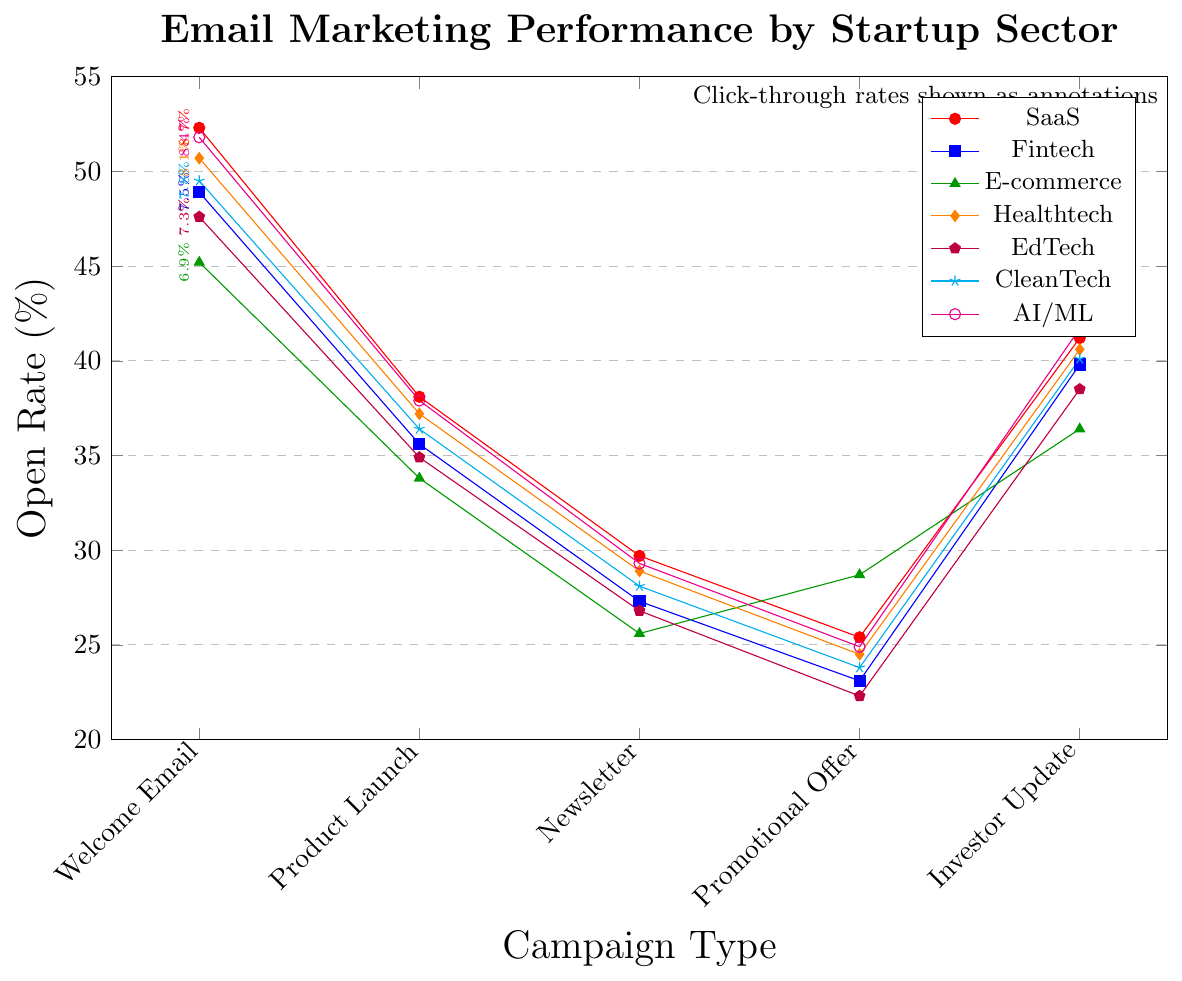How do the open rates of Welcome Emails compare across sectors? The highest open rate for Welcome Emails is in the SaaS sector at 52.3%, followed by AI/ML (51.8%), Healthtech (50.7%), CleanTech (49.5%), Fintech (48.9%), EdTech (47.6%), and finally E-commerce (45.2%).
Answer: SaaS sector has the highest open rates for Welcome Emails Which sector has the lowest click-through rate for newsletters? To find the sector with the lowest click-through rate for newsletters, compare the click-through percentages: SaaS (3.9%), Fintech (3.5%), E-commerce (3.2%), Healthtech (3.7%), EdTech (3.4%), CleanTech (3.6%), AI/ML (3.8%). E-commerce has the lowest click-through rate for newsletters at 3.2%.
Answer: E-commerce What is the average open rate for Product Launch emails across all sectors? Add up the open rates for Product Launch emails in all sectors: 38.1 (SaaS), 35.6 (Fintech), 33.8 (E-commerce), 37.2 (Healthtech), 34.9 (EdTech), 36.4 (CleanTech), and 37.9 (AI/ML). The sum is 253.9. Divide by the number of sectors (7) to get the average: 253.9/7 ≈ 36.27.
Answer: 36.27% What is the difference in open rates between Promotional Offers and Investor Updates for E-commerce? The open rate for Promotional Offers in E-commerce is 28.7% and for Investor Updates is 36.4%. The difference is 36.4% - 28.7% = 7.7%.
Answer: 7.7% Which sector has the steadiest open rates across different campaigns? Compare the fluctuations in open rates across campaigns for each sector: SaaS (52.3%-25.4% = 26.9%), Fintech (48.9%-23.1% = 25.8%), E-commerce (45.2%-25.6% = 19.6%), Healthtech (50.7%-24.5% = 26.2%), EdTech (47.6%-22.3% = 25.3%), CleanTech (49.5%-23.8% = 25.7%), AI/ML (51.8%-24.9% = 26.9%). E-commerce has the smallest range (19.6%), making it the steadiest.
Answer: E-commerce For which campaign type does the Healthtech sector have the highest open rate? Looking at the open rates for Healthtech across different campaigns: Welcome Email (50.7%), Product Launch (37.2%), Newsletter (28.9%), Promotional Offer (24.5%), Investor Update (40.6%). The highest open rate is for Welcome Email at 50.7%.
Answer: Welcome Email What is the combined click-through rate for EdTech sector across all campaign types? Sum the click-through rates for EdTech: Welcome Email (7.3%), Product Launch (4.6%), Newsletter (3.4%), Promotional Offer (2.5%), Investor Update (5.5%). The combined rate is 7.3% + 4.6% + 3.4% + 2.5% + 5.5% = 23.3%.
Answer: 23.3% By how much does the click-through rate of Investor Updates in AI/ML outperform that in Fintech? The click-through rate for Investor Updates in AI/ML is 6.2% and for Fintech is 5.7%. The outperformance is 6.2% - 5.7% = 0.5%.
Answer: 0.5% Among the Product Launch campaigns, which sector has the closest open rate to 36%? Review the open rates for Product Launch campaigns: SaaS (38.1%), Fintech (35.6%), E-commerce (33.8%), Healthtech (37.2%), EdTech (34.9%), CleanTech (36.4%), AI/ML (37.9%). CleanTech at 36.4% is closest to 36%.
Answer: CleanTech Is there any sector where the open rate for a Newsletter is higher than for a Product Launch? Compare open rates for Newsletters and Product Launch within each sector: SaaS (29.7% < 38.1%), Fintech (27.3% < 35.6%), E-commerce (25.6% < 33.8%), Healthtech (28.9% < 37.2%), EdTech (26.8% < 34.9%), CleanTech (28.1% < 36.4%), AI/ML (29.3% < 37.9%). No sector has a higher open rate for Newsletters than Product Launch.
Answer: No 